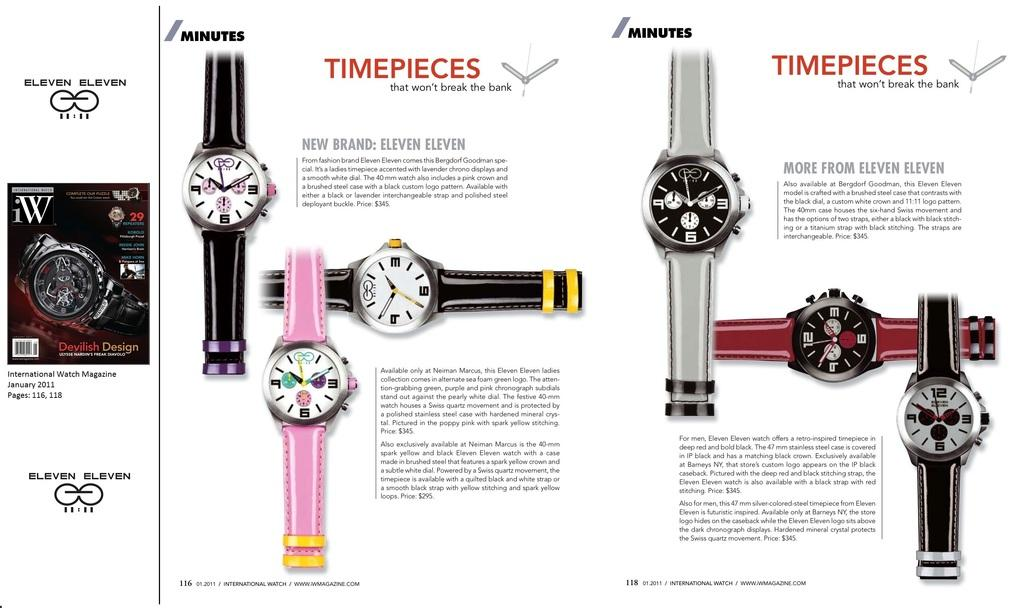<image>
Give a short and clear explanation of the subsequent image. An advertisement for watches of a new brand called eleven eleven. 